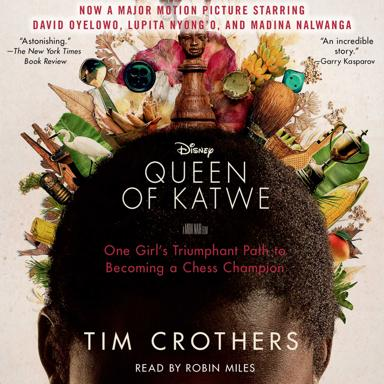Can you tell me more about the cultural significance of chess as depicted in 'Queen of Katwe'? In 'Queen of Katwe,' chess is not just a game but a metaphor for strategic thinking and overcoming life's challenges. It highlights how the game can be a tool for social mobility and intellectual growth, particularly significant in Phiona's journey from the slums to competing on global platforms. 